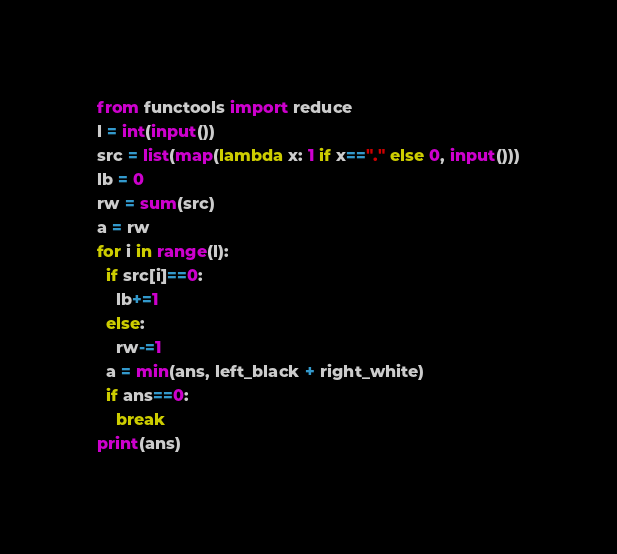Convert code to text. <code><loc_0><loc_0><loc_500><loc_500><_Python_>from functools import reduce
l = int(input())
src = list(map(lambda x: 1 if x=="." else 0, input()))
lb = 0
rw = sum(src)
a = rw
for i in range(l):
  if src[i]==0:
    lb+=1
  else:
    rw-=1
  a = min(ans, left_black + right_white)
  if ans==0:
    break
print(ans)</code> 